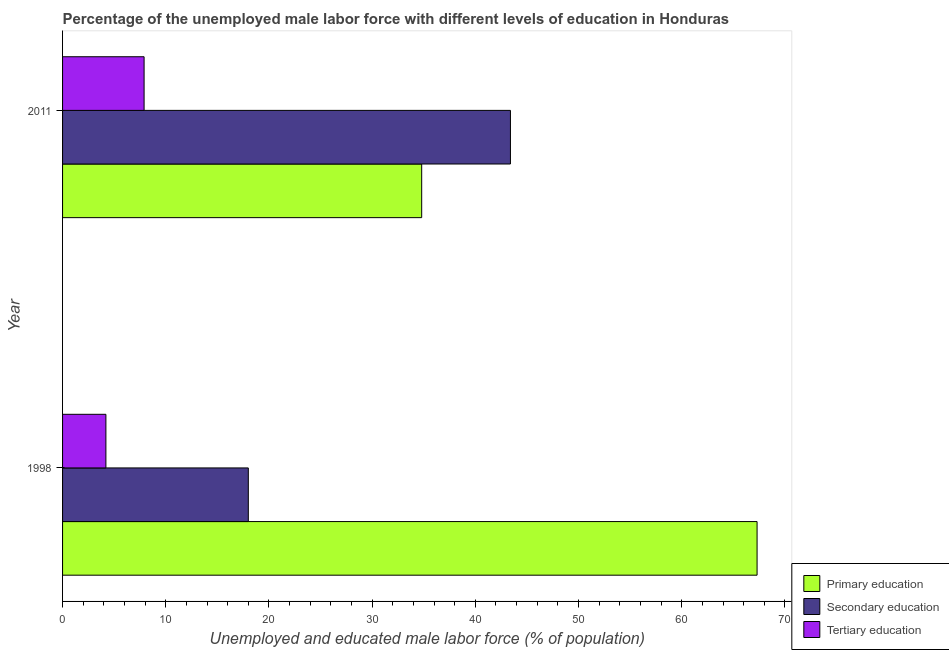How many different coloured bars are there?
Offer a very short reply. 3. Are the number of bars on each tick of the Y-axis equal?
Ensure brevity in your answer.  Yes. How many bars are there on the 1st tick from the top?
Your response must be concise. 3. What is the percentage of male labor force who received secondary education in 2011?
Offer a terse response. 43.4. Across all years, what is the maximum percentage of male labor force who received tertiary education?
Your answer should be compact. 7.9. Across all years, what is the minimum percentage of male labor force who received tertiary education?
Your answer should be very brief. 4.2. In which year was the percentage of male labor force who received tertiary education maximum?
Your answer should be compact. 2011. In which year was the percentage of male labor force who received tertiary education minimum?
Offer a very short reply. 1998. What is the total percentage of male labor force who received tertiary education in the graph?
Your answer should be compact. 12.1. What is the difference between the percentage of male labor force who received primary education in 1998 and that in 2011?
Give a very brief answer. 32.5. What is the difference between the percentage of male labor force who received secondary education in 2011 and the percentage of male labor force who received primary education in 1998?
Provide a short and direct response. -23.9. What is the average percentage of male labor force who received tertiary education per year?
Your response must be concise. 6.05. In the year 2011, what is the difference between the percentage of male labor force who received secondary education and percentage of male labor force who received tertiary education?
Offer a very short reply. 35.5. In how many years, is the percentage of male labor force who received tertiary education greater than 46 %?
Give a very brief answer. 0. What is the ratio of the percentage of male labor force who received primary education in 1998 to that in 2011?
Your answer should be compact. 1.93. Is the percentage of male labor force who received secondary education in 1998 less than that in 2011?
Give a very brief answer. Yes. Is the difference between the percentage of male labor force who received primary education in 1998 and 2011 greater than the difference between the percentage of male labor force who received secondary education in 1998 and 2011?
Your answer should be compact. Yes. What does the 3rd bar from the top in 1998 represents?
Give a very brief answer. Primary education. What does the 3rd bar from the bottom in 2011 represents?
Provide a short and direct response. Tertiary education. Is it the case that in every year, the sum of the percentage of male labor force who received primary education and percentage of male labor force who received secondary education is greater than the percentage of male labor force who received tertiary education?
Your response must be concise. Yes. How many years are there in the graph?
Offer a terse response. 2. What is the difference between two consecutive major ticks on the X-axis?
Your answer should be compact. 10. Are the values on the major ticks of X-axis written in scientific E-notation?
Give a very brief answer. No. Does the graph contain any zero values?
Offer a terse response. No. How many legend labels are there?
Your answer should be compact. 3. What is the title of the graph?
Ensure brevity in your answer.  Percentage of the unemployed male labor force with different levels of education in Honduras. Does "Industrial Nitrous Oxide" appear as one of the legend labels in the graph?
Keep it short and to the point. No. What is the label or title of the X-axis?
Your response must be concise. Unemployed and educated male labor force (% of population). What is the label or title of the Y-axis?
Give a very brief answer. Year. What is the Unemployed and educated male labor force (% of population) in Primary education in 1998?
Offer a terse response. 67.3. What is the Unemployed and educated male labor force (% of population) in Tertiary education in 1998?
Provide a short and direct response. 4.2. What is the Unemployed and educated male labor force (% of population) in Primary education in 2011?
Provide a short and direct response. 34.8. What is the Unemployed and educated male labor force (% of population) in Secondary education in 2011?
Provide a short and direct response. 43.4. What is the Unemployed and educated male labor force (% of population) in Tertiary education in 2011?
Make the answer very short. 7.9. Across all years, what is the maximum Unemployed and educated male labor force (% of population) in Primary education?
Provide a short and direct response. 67.3. Across all years, what is the maximum Unemployed and educated male labor force (% of population) of Secondary education?
Your answer should be compact. 43.4. Across all years, what is the maximum Unemployed and educated male labor force (% of population) in Tertiary education?
Your answer should be compact. 7.9. Across all years, what is the minimum Unemployed and educated male labor force (% of population) in Primary education?
Your answer should be very brief. 34.8. Across all years, what is the minimum Unemployed and educated male labor force (% of population) in Secondary education?
Your response must be concise. 18. Across all years, what is the minimum Unemployed and educated male labor force (% of population) of Tertiary education?
Your response must be concise. 4.2. What is the total Unemployed and educated male labor force (% of population) of Primary education in the graph?
Provide a succinct answer. 102.1. What is the total Unemployed and educated male labor force (% of population) of Secondary education in the graph?
Offer a terse response. 61.4. What is the difference between the Unemployed and educated male labor force (% of population) in Primary education in 1998 and that in 2011?
Give a very brief answer. 32.5. What is the difference between the Unemployed and educated male labor force (% of population) of Secondary education in 1998 and that in 2011?
Provide a short and direct response. -25.4. What is the difference between the Unemployed and educated male labor force (% of population) of Tertiary education in 1998 and that in 2011?
Give a very brief answer. -3.7. What is the difference between the Unemployed and educated male labor force (% of population) in Primary education in 1998 and the Unemployed and educated male labor force (% of population) in Secondary education in 2011?
Give a very brief answer. 23.9. What is the difference between the Unemployed and educated male labor force (% of population) in Primary education in 1998 and the Unemployed and educated male labor force (% of population) in Tertiary education in 2011?
Your answer should be very brief. 59.4. What is the average Unemployed and educated male labor force (% of population) of Primary education per year?
Offer a very short reply. 51.05. What is the average Unemployed and educated male labor force (% of population) of Secondary education per year?
Your response must be concise. 30.7. What is the average Unemployed and educated male labor force (% of population) in Tertiary education per year?
Offer a very short reply. 6.05. In the year 1998, what is the difference between the Unemployed and educated male labor force (% of population) in Primary education and Unemployed and educated male labor force (% of population) in Secondary education?
Offer a very short reply. 49.3. In the year 1998, what is the difference between the Unemployed and educated male labor force (% of population) of Primary education and Unemployed and educated male labor force (% of population) of Tertiary education?
Ensure brevity in your answer.  63.1. In the year 1998, what is the difference between the Unemployed and educated male labor force (% of population) in Secondary education and Unemployed and educated male labor force (% of population) in Tertiary education?
Offer a terse response. 13.8. In the year 2011, what is the difference between the Unemployed and educated male labor force (% of population) in Primary education and Unemployed and educated male labor force (% of population) in Secondary education?
Provide a succinct answer. -8.6. In the year 2011, what is the difference between the Unemployed and educated male labor force (% of population) in Primary education and Unemployed and educated male labor force (% of population) in Tertiary education?
Offer a very short reply. 26.9. In the year 2011, what is the difference between the Unemployed and educated male labor force (% of population) of Secondary education and Unemployed and educated male labor force (% of population) of Tertiary education?
Provide a succinct answer. 35.5. What is the ratio of the Unemployed and educated male labor force (% of population) of Primary education in 1998 to that in 2011?
Provide a short and direct response. 1.93. What is the ratio of the Unemployed and educated male labor force (% of population) of Secondary education in 1998 to that in 2011?
Your response must be concise. 0.41. What is the ratio of the Unemployed and educated male labor force (% of population) of Tertiary education in 1998 to that in 2011?
Your response must be concise. 0.53. What is the difference between the highest and the second highest Unemployed and educated male labor force (% of population) of Primary education?
Provide a succinct answer. 32.5. What is the difference between the highest and the second highest Unemployed and educated male labor force (% of population) of Secondary education?
Keep it short and to the point. 25.4. What is the difference between the highest and the lowest Unemployed and educated male labor force (% of population) of Primary education?
Keep it short and to the point. 32.5. What is the difference between the highest and the lowest Unemployed and educated male labor force (% of population) of Secondary education?
Offer a very short reply. 25.4. 